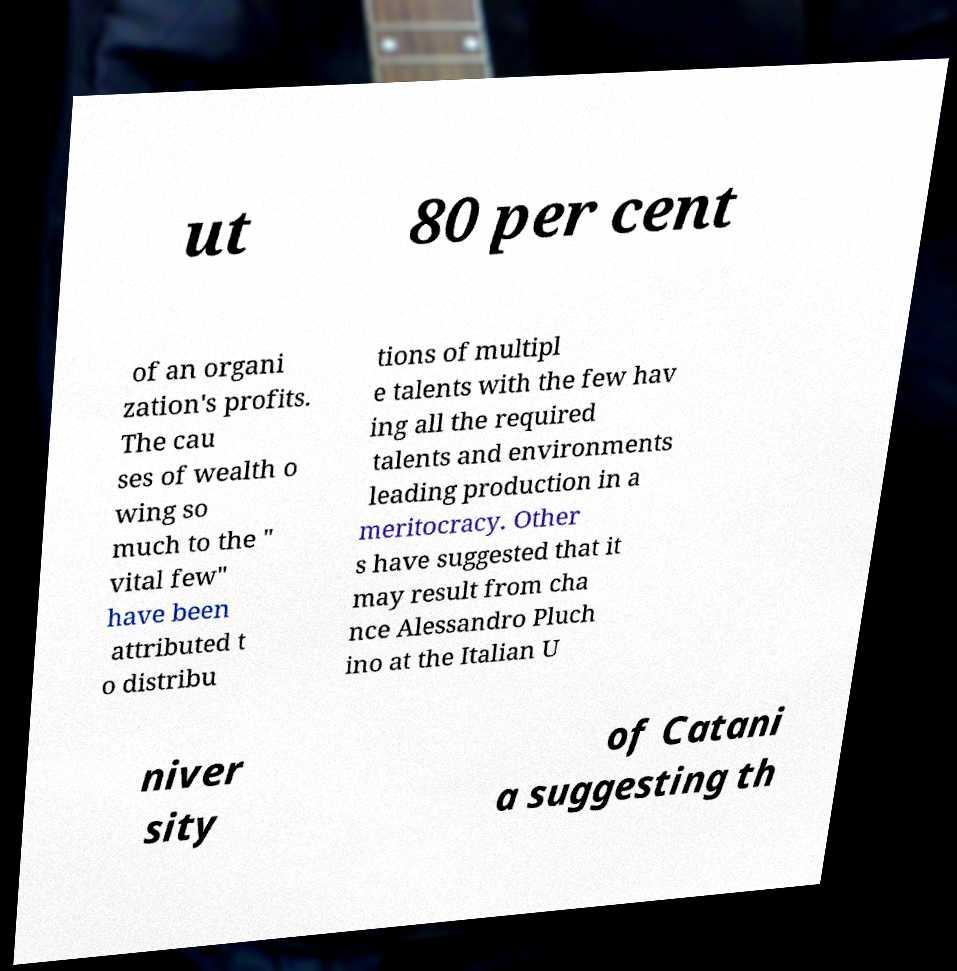Can you read and provide the text displayed in the image?This photo seems to have some interesting text. Can you extract and type it out for me? ut 80 per cent of an organi zation's profits. The cau ses of wealth o wing so much to the " vital few" have been attributed t o distribu tions of multipl e talents with the few hav ing all the required talents and environments leading production in a meritocracy. Other s have suggested that it may result from cha nce Alessandro Pluch ino at the Italian U niver sity of Catani a suggesting th 